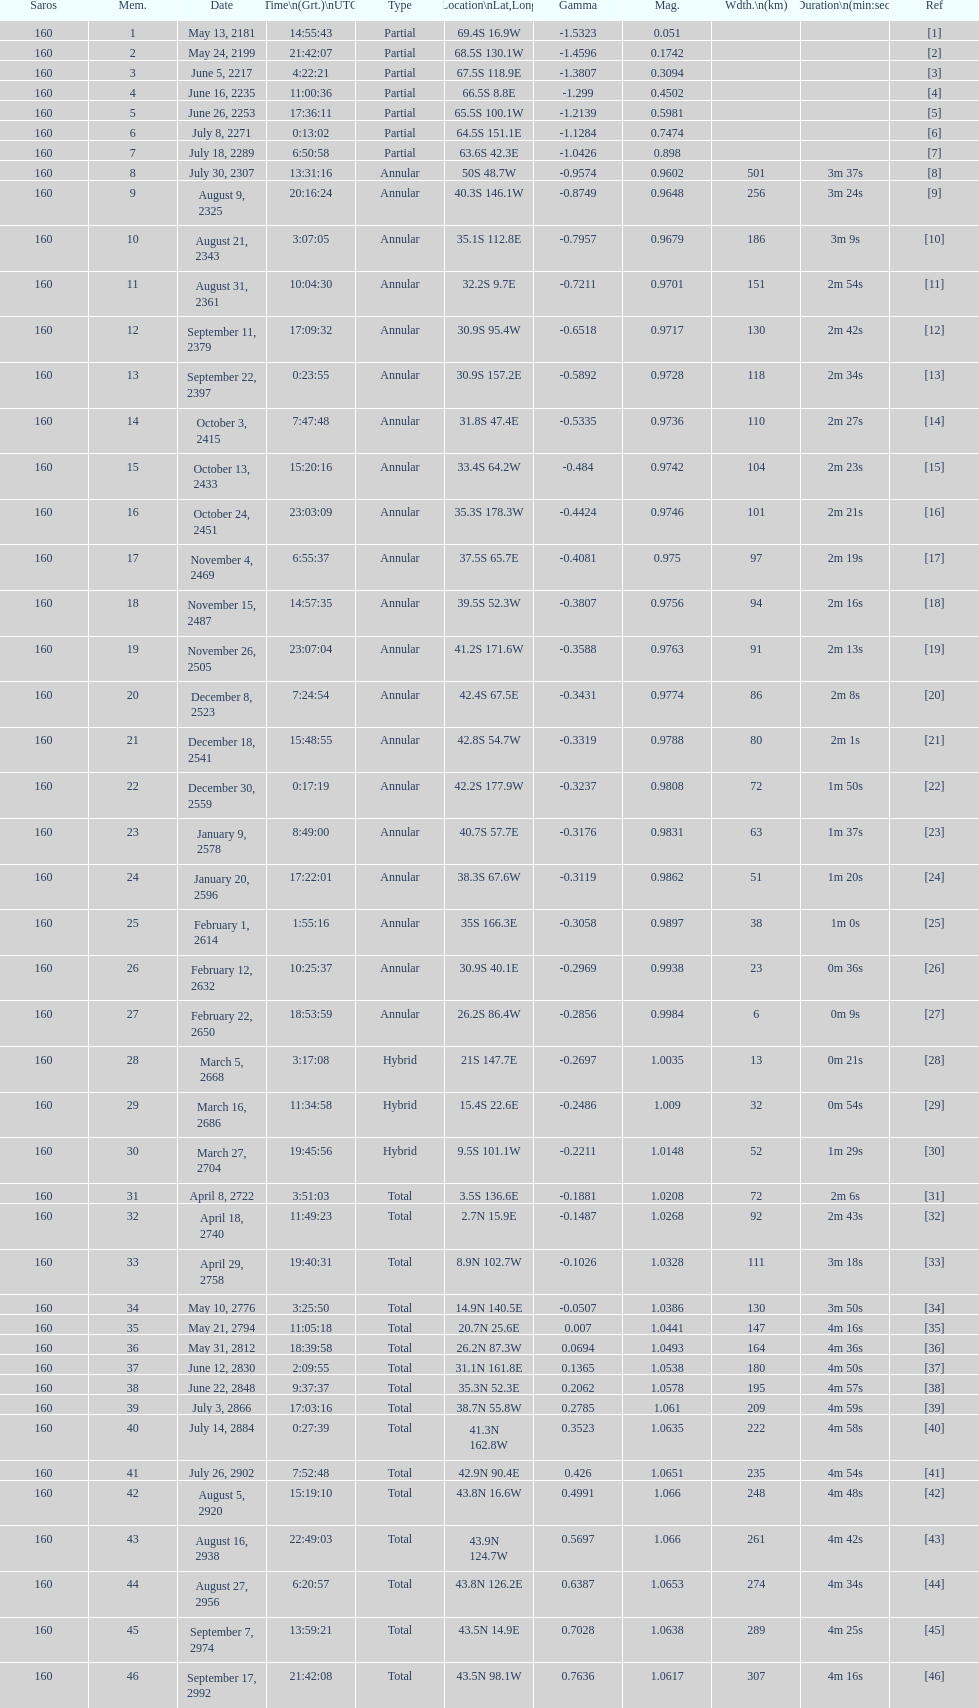When did the first solar saros with a magnitude of greater than 1.00 occur? March 5, 2668. 